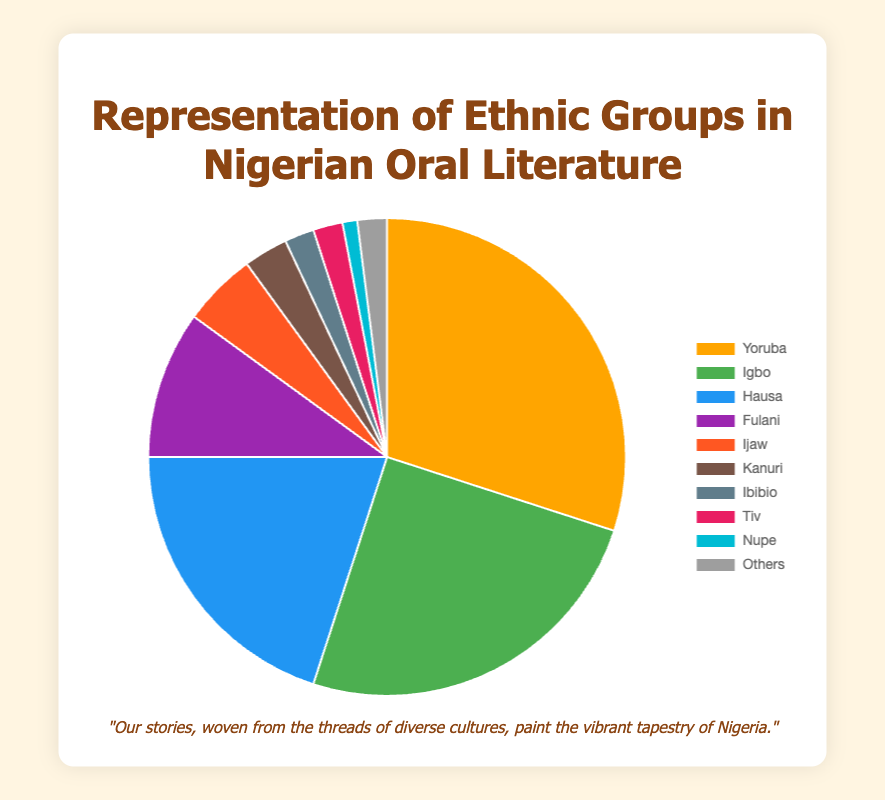What percentage of Nigerian oral literature representation do the Yoruba and Igbo ethnic groups collectively have? To find the collective representation, you need to sum the percentages of the Yoruba (30%) and Igbo (25%). Hence, 30 + 25 = 55%
Answer: 55% Which ethnic group has the lowest representation in Nigerian oral literature? From the pie chart data, the Nupe ethnic group has the lowest representation at 1%
Answer: Nupe How does the representation of Hausa compare to that of Fulani? The Hausa representation is 20%, while Fulani is 10%. Therefore, Hausa representation is greater by 10 percentage points
Answer: Hausa What is the combined percentage of the ethnic groups with the smallest representation—Ibibio, Tiv, and Nupe? Add the percentages for Ibibio (2%), Tiv (2%), and Nupe (1%). Hence, 2 + 2 + 1 = 5%
Answer: 5% Which ethnic group has more representation than both the Ijaw and Kanuri combined? The combined percentage for Ijaw and Kanuri is 5% + 3% = 8%. The Yoruba, Igbo, and Hausa groups have more than 8% representation. The Yoruba with 30%, Igbo with 25%, and Hausa with 20% all exceed the combined percentage
Answer: Yoruba, Igbo, or Hausa What is the ratio of the Hausa representation to the Ijaw representation? The ratio is obtained by dividing the Hausa (20%) by the Ijaw (5%). Hence, 20 / 5 = 4:1
Answer: 4:1 How does the visual color of Yoruba representation stand out from the others in the chart? Yoruba representation is visually marked by a vivid orange color that contrasts sharply with the other colors used for different ethnic groups
Answer: Orange If you combine the percentages of all ethnic groups together except for Yoruba, what is their collective percentage? Subtract the Yoruba percentage (30%) from the total (100%). Hence, 100 - 30 = 70%
Answer: 70% Considering the pie chart, which ethnic groups collectively represent half of the Nigerian oral literature? Collectively, the Yoruba (30%) and Igbo (25%) represent 55%, which is more than half, but to find exactly half, adding Hausa's (20%) and Fulani's (10%) representations gives exactly 30% + 25% = 50%
Answer: Yoruba, Igbo Which group represented next to the 'Others' has more visible space in the pie chart? From the chart's visual, the group right next to 'Others' is Nupe with less representation space. Hence, any group other than Nupe ('Ibibio', 'Tiv') has a proportion larger than Nupe's visual space
Answer: Ibibio or Tiv 